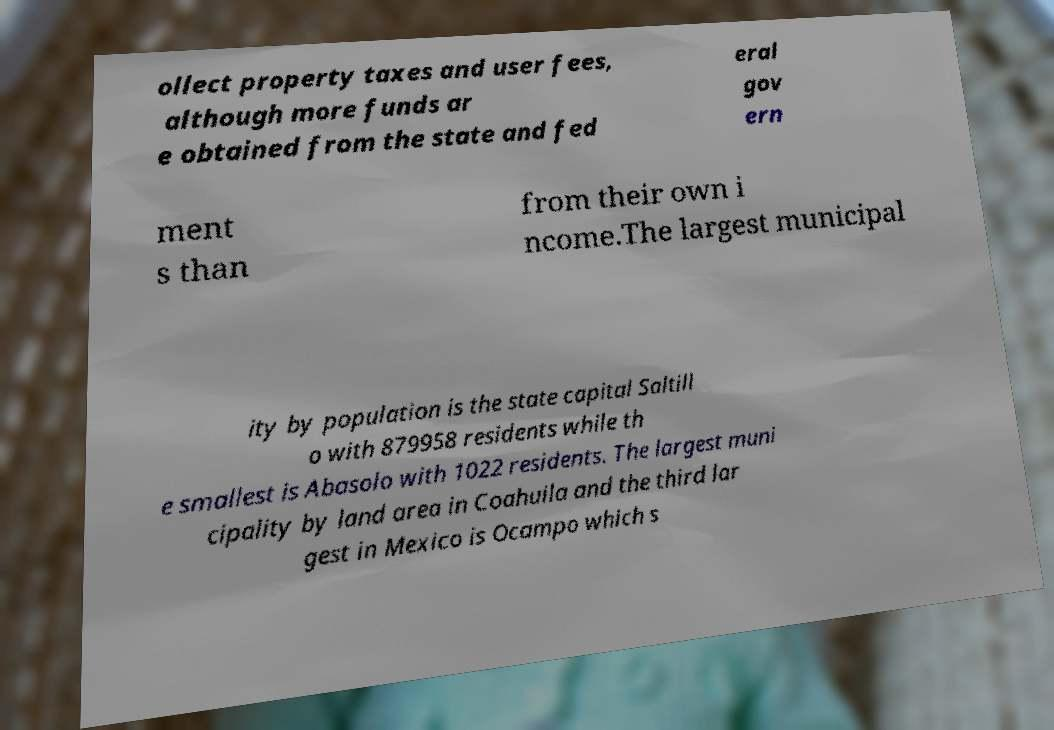Can you read and provide the text displayed in the image?This photo seems to have some interesting text. Can you extract and type it out for me? ollect property taxes and user fees, although more funds ar e obtained from the state and fed eral gov ern ment s than from their own i ncome.The largest municipal ity by population is the state capital Saltill o with 879958 residents while th e smallest is Abasolo with 1022 residents. The largest muni cipality by land area in Coahuila and the third lar gest in Mexico is Ocampo which s 